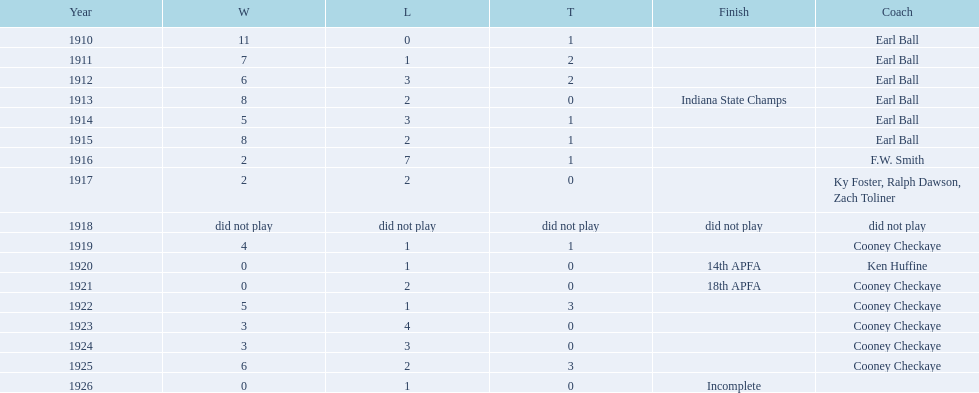Write the full table. {'header': ['Year', 'W', 'L', 'T', 'Finish', 'Coach'], 'rows': [['1910', '11', '0', '1', '', 'Earl Ball'], ['1911', '7', '1', '2', '', 'Earl Ball'], ['1912', '6', '3', '2', '', 'Earl Ball'], ['1913', '8', '2', '0', 'Indiana State Champs', 'Earl Ball'], ['1914', '5', '3', '1', '', 'Earl Ball'], ['1915', '8', '2', '1', '', 'Earl Ball'], ['1916', '2', '7', '1', '', 'F.W. Smith'], ['1917', '2', '2', '0', '', 'Ky Foster, Ralph Dawson, Zach Toliner'], ['1918', 'did not play', 'did not play', 'did not play', 'did not play', 'did not play'], ['1919', '4', '1', '1', '', 'Cooney Checkaye'], ['1920', '0', '1', '0', '14th APFA', 'Ken Huffine'], ['1921', '0', '2', '0', '18th APFA', 'Cooney Checkaye'], ['1922', '5', '1', '3', '', 'Cooney Checkaye'], ['1923', '3', '4', '0', '', 'Cooney Checkaye'], ['1924', '3', '3', '0', '', 'Cooney Checkaye'], ['1925', '6', '2', '3', '', 'Cooney Checkaye'], ['1926', '0', '1', '0', 'Incomplete', '']]} Who coached the muncie flyers to an indiana state championship? Earl Ball. 